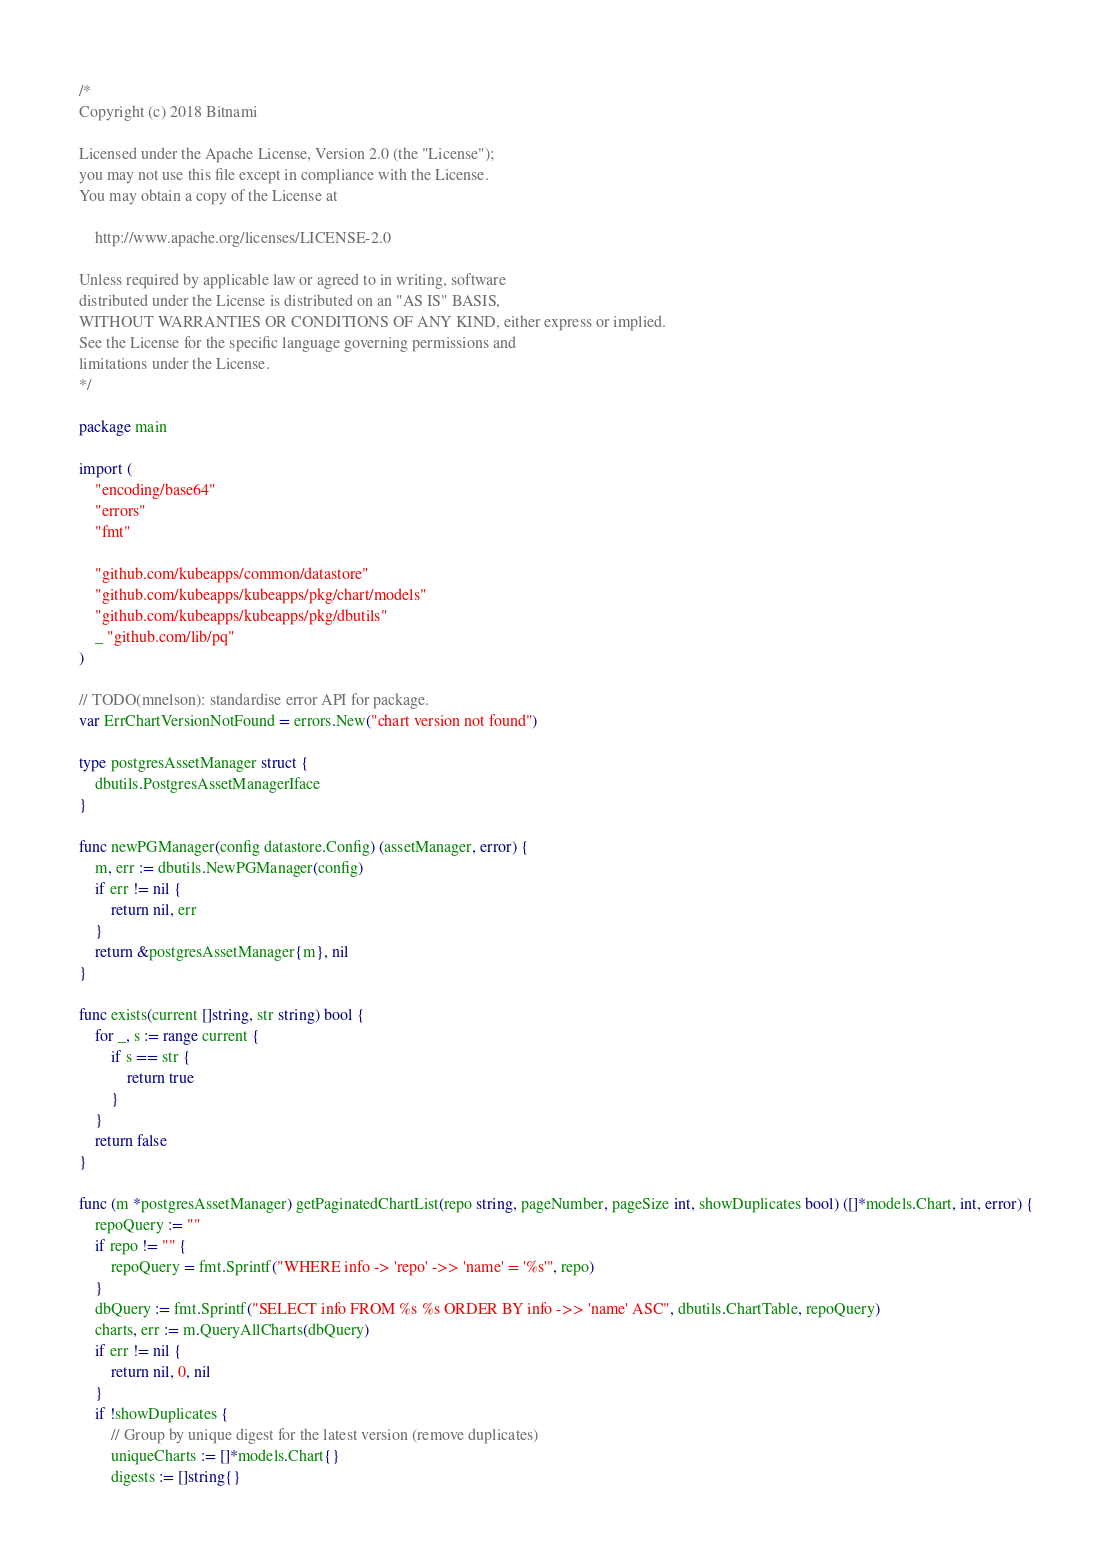Convert code to text. <code><loc_0><loc_0><loc_500><loc_500><_Go_>/*
Copyright (c) 2018 Bitnami

Licensed under the Apache License, Version 2.0 (the "License");
you may not use this file except in compliance with the License.
You may obtain a copy of the License at

    http://www.apache.org/licenses/LICENSE-2.0

Unless required by applicable law or agreed to in writing, software
distributed under the License is distributed on an "AS IS" BASIS,
WITHOUT WARRANTIES OR CONDITIONS OF ANY KIND, either express or implied.
See the License for the specific language governing permissions and
limitations under the License.
*/

package main

import (
	"encoding/base64"
	"errors"
	"fmt"

	"github.com/kubeapps/common/datastore"
	"github.com/kubeapps/kubeapps/pkg/chart/models"
	"github.com/kubeapps/kubeapps/pkg/dbutils"
	_ "github.com/lib/pq"
)

// TODO(mnelson): standardise error API for package.
var ErrChartVersionNotFound = errors.New("chart version not found")

type postgresAssetManager struct {
	dbutils.PostgresAssetManagerIface
}

func newPGManager(config datastore.Config) (assetManager, error) {
	m, err := dbutils.NewPGManager(config)
	if err != nil {
		return nil, err
	}
	return &postgresAssetManager{m}, nil
}

func exists(current []string, str string) bool {
	for _, s := range current {
		if s == str {
			return true
		}
	}
	return false
}

func (m *postgresAssetManager) getPaginatedChartList(repo string, pageNumber, pageSize int, showDuplicates bool) ([]*models.Chart, int, error) {
	repoQuery := ""
	if repo != "" {
		repoQuery = fmt.Sprintf("WHERE info -> 'repo' ->> 'name' = '%s'", repo)
	}
	dbQuery := fmt.Sprintf("SELECT info FROM %s %s ORDER BY info ->> 'name' ASC", dbutils.ChartTable, repoQuery)
	charts, err := m.QueryAllCharts(dbQuery)
	if err != nil {
		return nil, 0, nil
	}
	if !showDuplicates {
		// Group by unique digest for the latest version (remove duplicates)
		uniqueCharts := []*models.Chart{}
		digests := []string{}</code> 